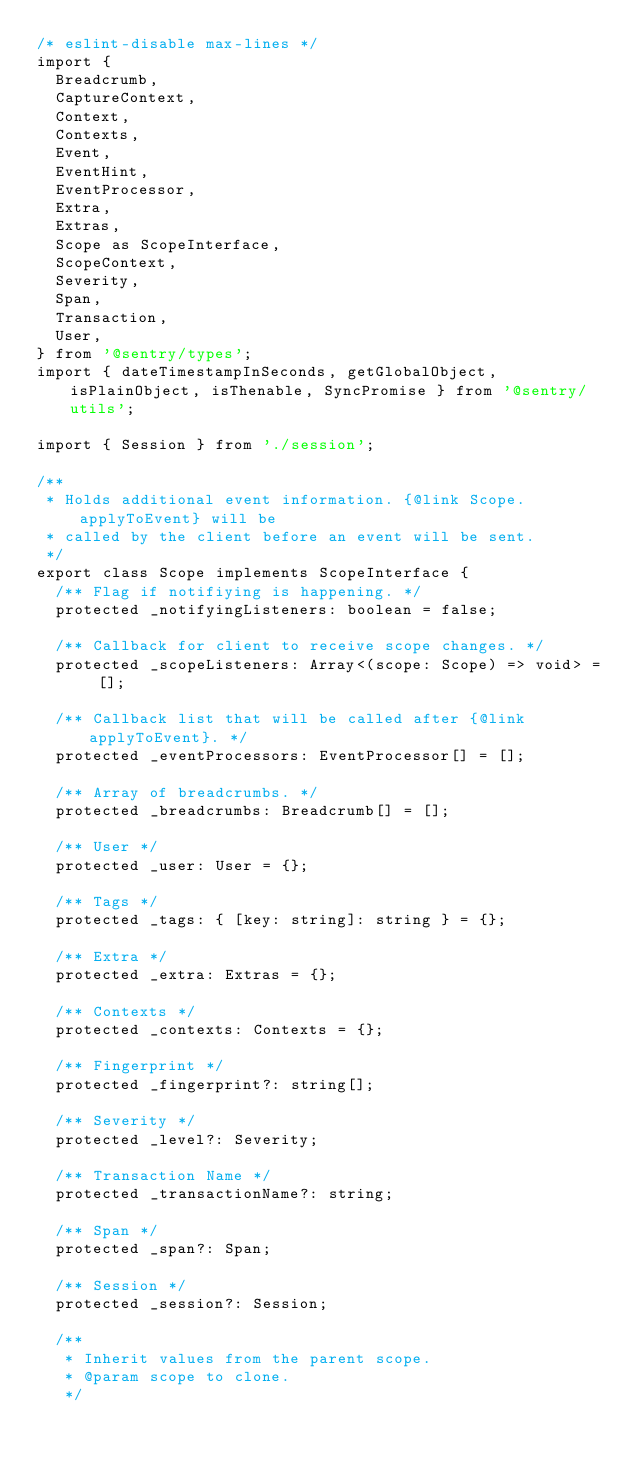Convert code to text. <code><loc_0><loc_0><loc_500><loc_500><_TypeScript_>/* eslint-disable max-lines */
import {
  Breadcrumb,
  CaptureContext,
  Context,
  Contexts,
  Event,
  EventHint,
  EventProcessor,
  Extra,
  Extras,
  Scope as ScopeInterface,
  ScopeContext,
  Severity,
  Span,
  Transaction,
  User,
} from '@sentry/types';
import { dateTimestampInSeconds, getGlobalObject, isPlainObject, isThenable, SyncPromise } from '@sentry/utils';

import { Session } from './session';

/**
 * Holds additional event information. {@link Scope.applyToEvent} will be
 * called by the client before an event will be sent.
 */
export class Scope implements ScopeInterface {
  /** Flag if notifiying is happening. */
  protected _notifyingListeners: boolean = false;

  /** Callback for client to receive scope changes. */
  protected _scopeListeners: Array<(scope: Scope) => void> = [];

  /** Callback list that will be called after {@link applyToEvent}. */
  protected _eventProcessors: EventProcessor[] = [];

  /** Array of breadcrumbs. */
  protected _breadcrumbs: Breadcrumb[] = [];

  /** User */
  protected _user: User = {};

  /** Tags */
  protected _tags: { [key: string]: string } = {};

  /** Extra */
  protected _extra: Extras = {};

  /** Contexts */
  protected _contexts: Contexts = {};

  /** Fingerprint */
  protected _fingerprint?: string[];

  /** Severity */
  protected _level?: Severity;

  /** Transaction Name */
  protected _transactionName?: string;

  /** Span */
  protected _span?: Span;

  /** Session */
  protected _session?: Session;

  /**
   * Inherit values from the parent scope.
   * @param scope to clone.
   */</code> 